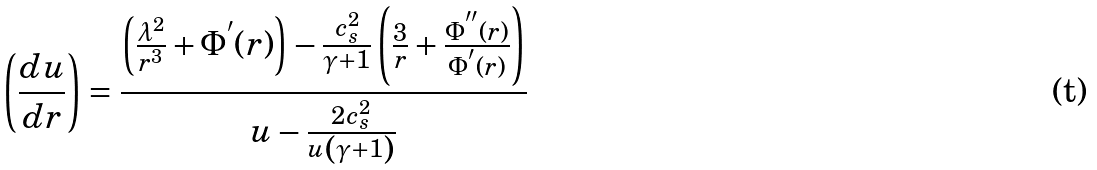Convert formula to latex. <formula><loc_0><loc_0><loc_500><loc_500>\left ( \frac { d u } { d r } \right ) = \frac { \left ( \frac { \lambda ^ { 2 } } { r ^ { 3 } } + \Phi ^ { ^ { \prime } } ( r ) \right ) - \frac { c _ { s } ^ { 2 } } { \gamma + 1 } \left ( \frac { 3 } { r } + \frac { \Phi ^ { ^ { \prime \prime } } ( r ) } { \Phi ^ { ^ { \prime } } ( r ) } \right ) } { u - \frac { 2 c _ { s } ^ { 2 } } { u \left ( \gamma + 1 \right ) } }</formula> 